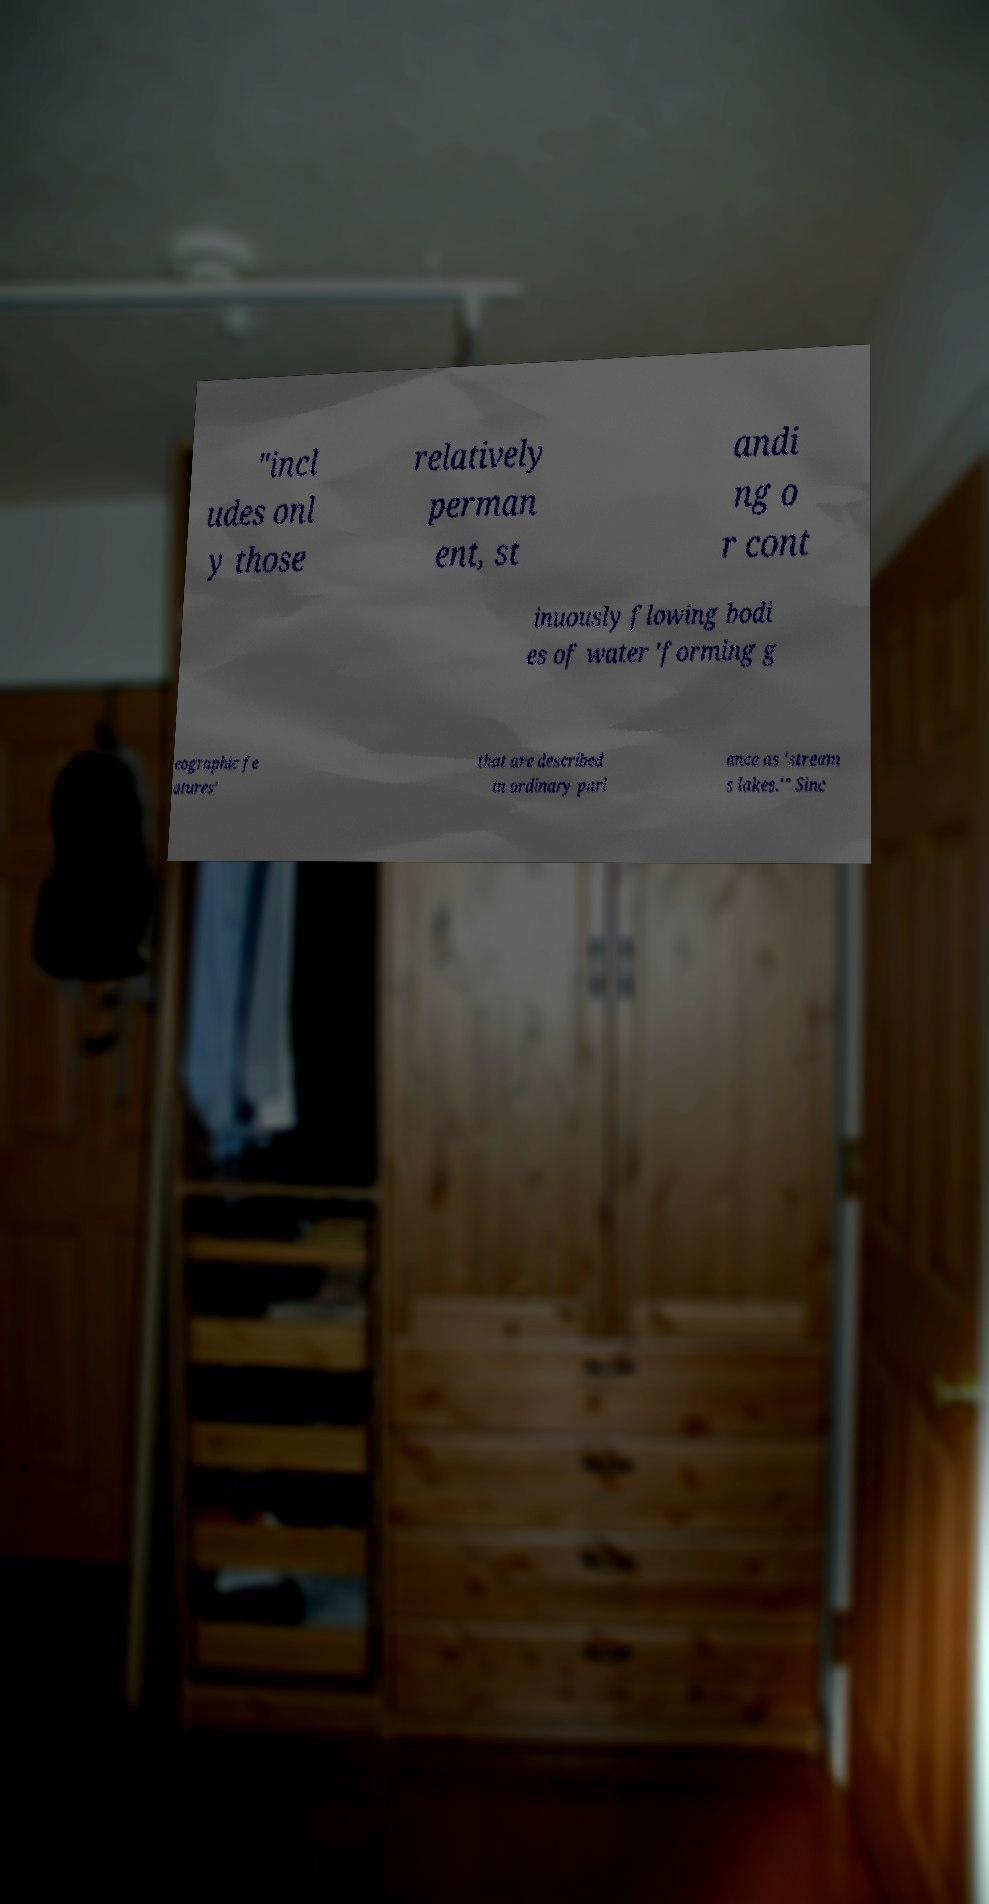Could you extract and type out the text from this image? "incl udes onl y those relatively perman ent, st andi ng o r cont inuously flowing bodi es of water 'forming g eographic fe atures' that are described in ordinary parl ance as 'stream s lakes.'" Sinc 